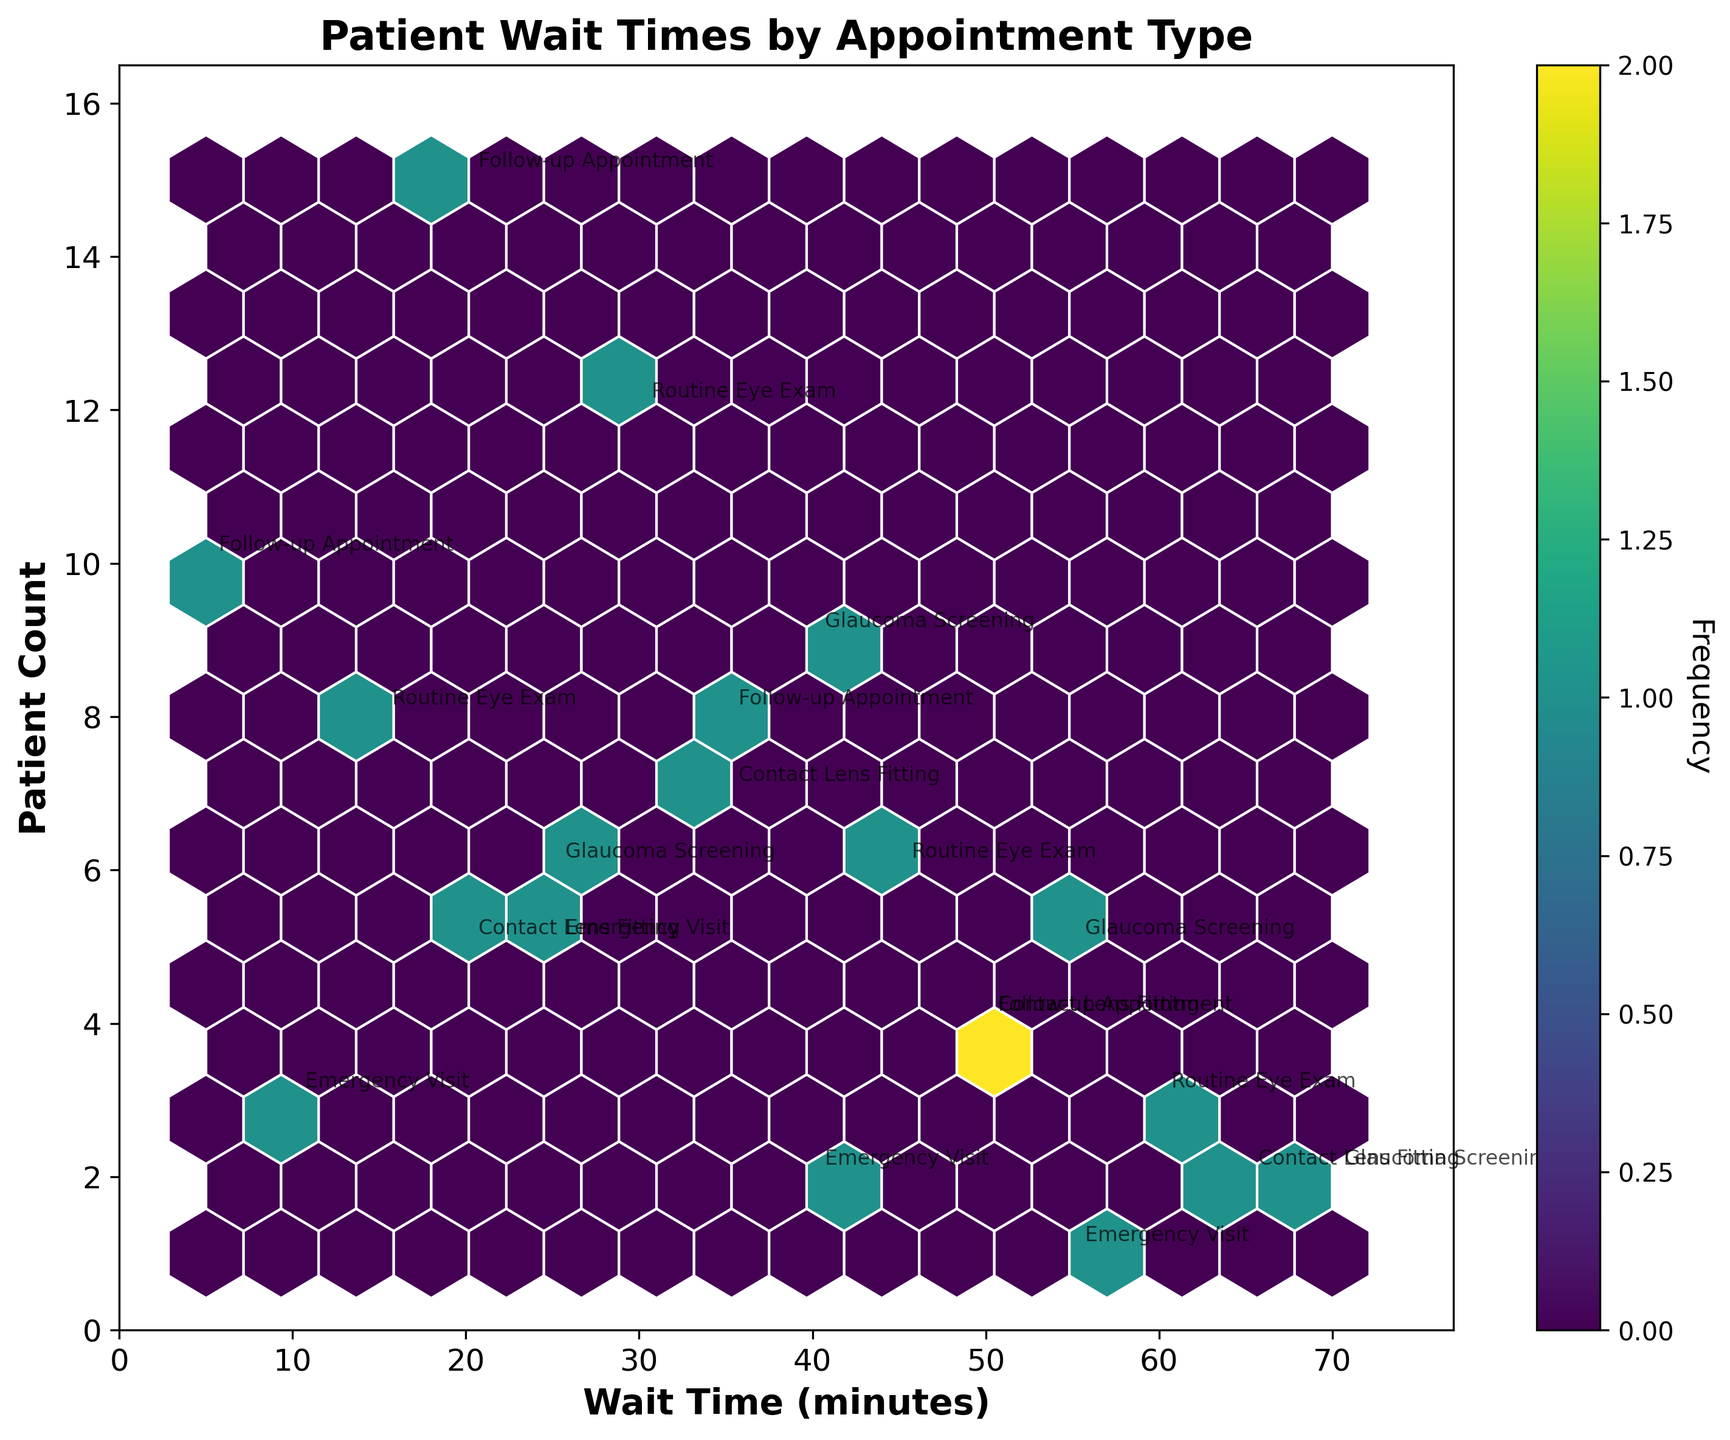What is the title of the plot? The title of the plot is displayed at the top center of the figure.
Answer: Patient Wait Times by Appointment Type What are the labels of the x and y axes? The x-axis represents 'Wait Time (minutes)', and the y-axis represents 'Patient Count'.
Answer: Wait Time (minutes) and Patient Count Between which wait times is the highest frequency of patient counts observed? The color intensity in a hexbin plot indicates frequency. The highest frequency can be observed where the hexbins are darkest.
Answer: Around 20-35 minutes Which appointment type has the highest patient count at a wait time of around 20 minutes? By combining wait time and patient count, we can reference the annotations near 20 minutes. Follow-up Appointments have the highest patient count around this time.
Answer: Follow-up Appointment How does the waiting time for 'Routine Eye Exam' compare with 'Emergency Visit'? By referencing both the wait time ranges and the data points' relative positions, 'Routine Eye Exam' tends to have higher wait times compared to 'Emergency Visit'.
Answer: Routine Eye Exam has higher wait times What is the approximate frequency of patients with a wait time around 60 minutes? The frequency is indicated by the color intensity in the hexbin plot. We check the color against the color bar for hay towards 60 minutes.
Answer: Low frequency Which appointment type has the widest range of wait times? By observing the spread of annotated points, 'Routine Eye Exam' spans from 15 minutes to 60 minutes, indicating the widest range.
Answer: Routine Eye Exam If the 'Emergency Visit' appointment type is crucial, what might be a concern based on their wait times and patient counts? Considering that 'Emergency Visit' typically has lower wait times, but also lower patient counts, the concern might be how few emergencies are actually observed vis-a-vis timely provision.
Answer: Lower patient counts but timely visits What is the most common patient count for 'Contact Lens Fitting'? The patient count can be identified by observing the annotated numbers and the density of the hexbins for 'Contact Lens Fitting.' The most common numbers are around 7.
Answer: 7 Which appointment type shows the most number of high-frequency zones close to the lower end of wait times? High-frequency zones close to lower wait times can be identified by dark hexagons near the lower wait times. 'Follow-up Appointment' shows this pattern around 5-20 minutes with dense zones.
Answer: Follow-up Appointment 